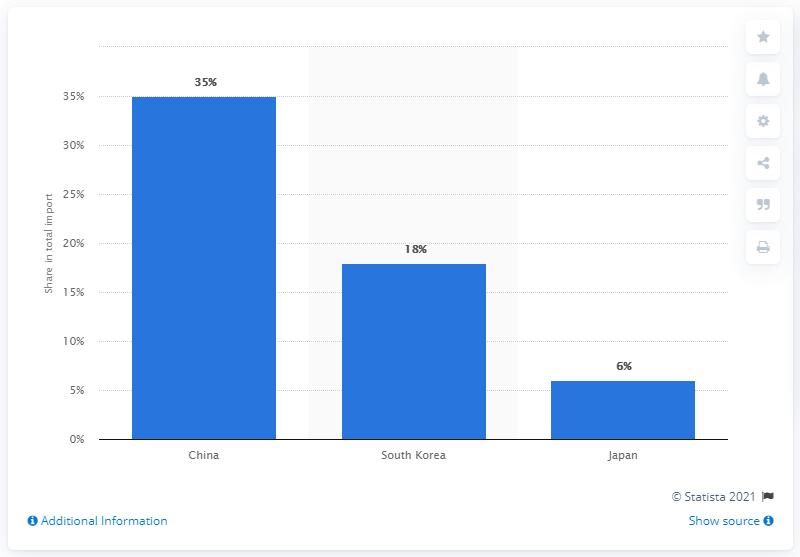Draw attention to some important aspects in this diagram. According to data from 2019, China was the most important import partner for Vietnam. 